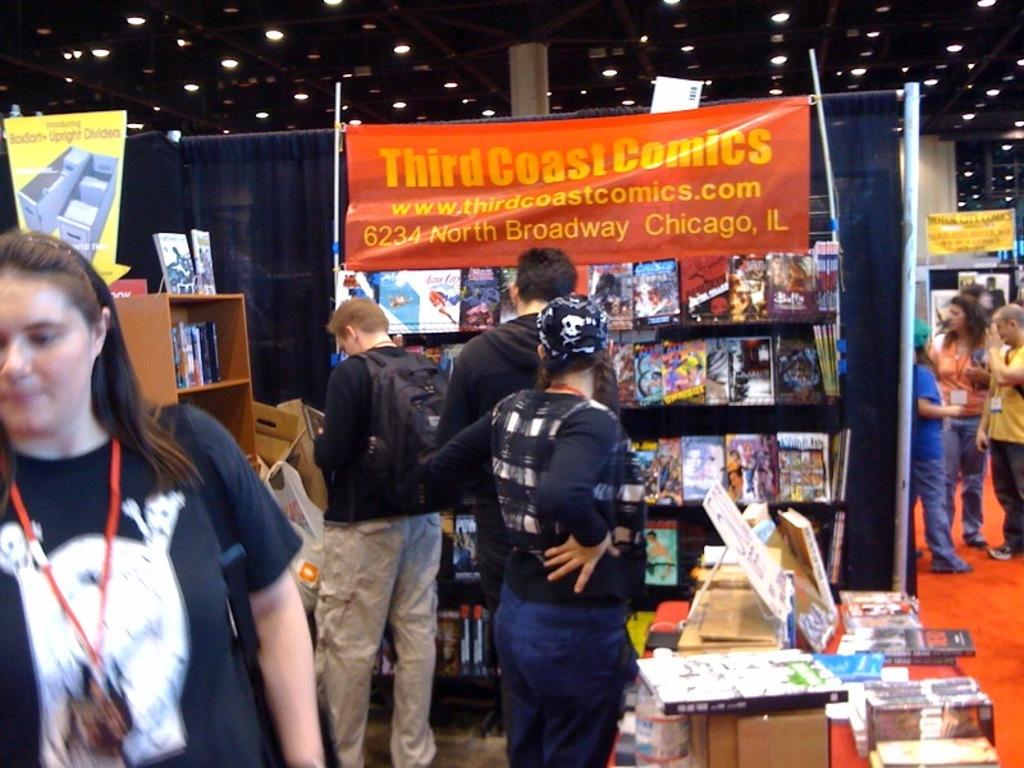What's the name of the comic book seller on the poster?
Keep it short and to the point. Third coast comics. What city is third coast comics in?
Offer a very short reply. Chicago. 